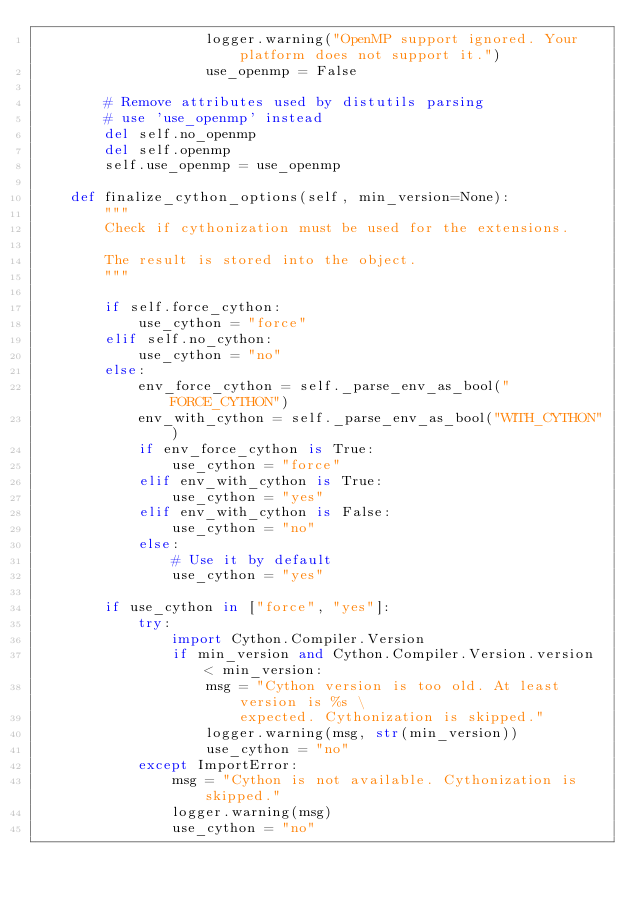<code> <loc_0><loc_0><loc_500><loc_500><_Python_>                    logger.warning("OpenMP support ignored. Your platform does not support it.")
                    use_openmp = False

        # Remove attributes used by distutils parsing
        # use 'use_openmp' instead
        del self.no_openmp
        del self.openmp
        self.use_openmp = use_openmp

    def finalize_cython_options(self, min_version=None):
        """
        Check if cythonization must be used for the extensions.

        The result is stored into the object.
        """

        if self.force_cython:
            use_cython = "force"
        elif self.no_cython:
            use_cython = "no"
        else:
            env_force_cython = self._parse_env_as_bool("FORCE_CYTHON")
            env_with_cython = self._parse_env_as_bool("WITH_CYTHON")
            if env_force_cython is True:
                use_cython = "force"
            elif env_with_cython is True:
                use_cython = "yes"
            elif env_with_cython is False:
                use_cython = "no"
            else:
                # Use it by default
                use_cython = "yes"

        if use_cython in ["force", "yes"]:
            try:
                import Cython.Compiler.Version
                if min_version and Cython.Compiler.Version.version < min_version:
                    msg = "Cython version is too old. At least version is %s \
                        expected. Cythonization is skipped."
                    logger.warning(msg, str(min_version))
                    use_cython = "no"
            except ImportError:
                msg = "Cython is not available. Cythonization is skipped."
                logger.warning(msg)
                use_cython = "no"
</code> 